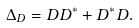<formula> <loc_0><loc_0><loc_500><loc_500>\Delta _ { D } = D D ^ { * } + D ^ { * } D .</formula> 